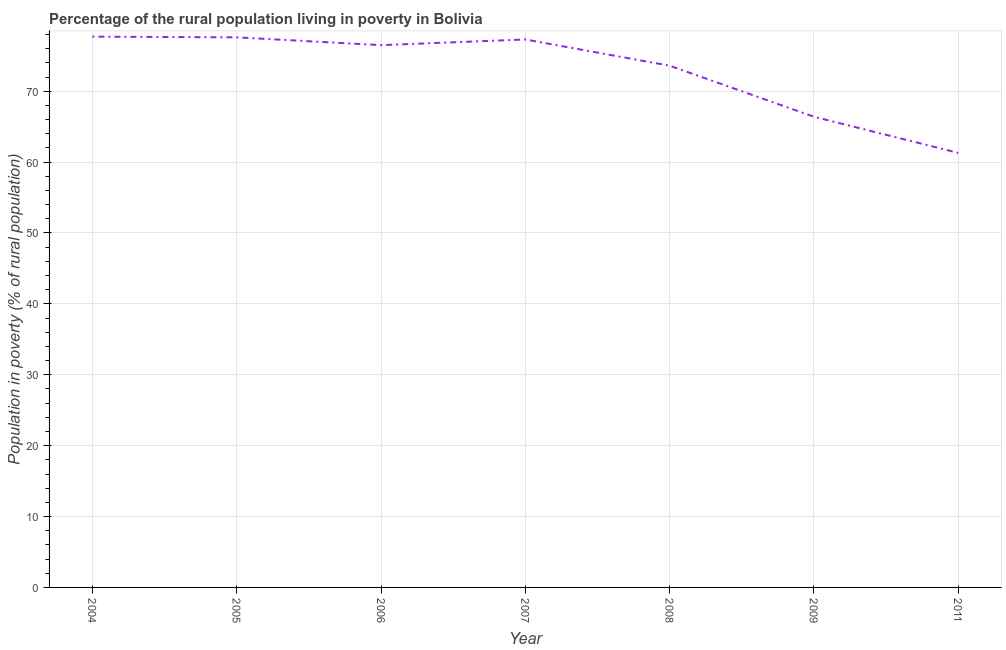What is the percentage of rural population living below poverty line in 2011?
Provide a succinct answer. 61.3. Across all years, what is the maximum percentage of rural population living below poverty line?
Provide a succinct answer. 77.7. Across all years, what is the minimum percentage of rural population living below poverty line?
Your answer should be very brief. 61.3. In which year was the percentage of rural population living below poverty line maximum?
Offer a terse response. 2004. In which year was the percentage of rural population living below poverty line minimum?
Your answer should be very brief. 2011. What is the sum of the percentage of rural population living below poverty line?
Offer a terse response. 510.4. What is the difference between the percentage of rural population living below poverty line in 2005 and 2011?
Offer a very short reply. 16.3. What is the average percentage of rural population living below poverty line per year?
Ensure brevity in your answer.  72.91. What is the median percentage of rural population living below poverty line?
Your answer should be very brief. 76.5. What is the ratio of the percentage of rural population living below poverty line in 2008 to that in 2011?
Your answer should be very brief. 1.2. Is the percentage of rural population living below poverty line in 2006 less than that in 2008?
Your answer should be compact. No. What is the difference between the highest and the second highest percentage of rural population living below poverty line?
Provide a short and direct response. 0.1. Is the sum of the percentage of rural population living below poverty line in 2006 and 2007 greater than the maximum percentage of rural population living below poverty line across all years?
Your response must be concise. Yes. What is the difference between the highest and the lowest percentage of rural population living below poverty line?
Make the answer very short. 16.4. Does the percentage of rural population living below poverty line monotonically increase over the years?
Ensure brevity in your answer.  No. How many years are there in the graph?
Your answer should be very brief. 7. Does the graph contain any zero values?
Keep it short and to the point. No. What is the title of the graph?
Ensure brevity in your answer.  Percentage of the rural population living in poverty in Bolivia. What is the label or title of the Y-axis?
Your answer should be very brief. Population in poverty (% of rural population). What is the Population in poverty (% of rural population) in 2004?
Your answer should be very brief. 77.7. What is the Population in poverty (% of rural population) in 2005?
Provide a succinct answer. 77.6. What is the Population in poverty (% of rural population) of 2006?
Provide a short and direct response. 76.5. What is the Population in poverty (% of rural population) of 2007?
Your answer should be very brief. 77.3. What is the Population in poverty (% of rural population) of 2008?
Provide a succinct answer. 73.6. What is the Population in poverty (% of rural population) of 2009?
Give a very brief answer. 66.4. What is the Population in poverty (% of rural population) in 2011?
Offer a terse response. 61.3. What is the difference between the Population in poverty (% of rural population) in 2004 and 2006?
Make the answer very short. 1.2. What is the difference between the Population in poverty (% of rural population) in 2005 and 2009?
Ensure brevity in your answer.  11.2. What is the difference between the Population in poverty (% of rural population) in 2005 and 2011?
Ensure brevity in your answer.  16.3. What is the difference between the Population in poverty (% of rural population) in 2006 and 2008?
Your response must be concise. 2.9. What is the difference between the Population in poverty (% of rural population) in 2006 and 2009?
Your response must be concise. 10.1. What is the difference between the Population in poverty (% of rural population) in 2006 and 2011?
Provide a succinct answer. 15.2. What is the ratio of the Population in poverty (% of rural population) in 2004 to that in 2005?
Your response must be concise. 1. What is the ratio of the Population in poverty (% of rural population) in 2004 to that in 2008?
Give a very brief answer. 1.06. What is the ratio of the Population in poverty (% of rural population) in 2004 to that in 2009?
Keep it short and to the point. 1.17. What is the ratio of the Population in poverty (% of rural population) in 2004 to that in 2011?
Keep it short and to the point. 1.27. What is the ratio of the Population in poverty (% of rural population) in 2005 to that in 2006?
Provide a succinct answer. 1.01. What is the ratio of the Population in poverty (% of rural population) in 2005 to that in 2008?
Your answer should be very brief. 1.05. What is the ratio of the Population in poverty (% of rural population) in 2005 to that in 2009?
Your answer should be compact. 1.17. What is the ratio of the Population in poverty (% of rural population) in 2005 to that in 2011?
Ensure brevity in your answer.  1.27. What is the ratio of the Population in poverty (% of rural population) in 2006 to that in 2007?
Provide a succinct answer. 0.99. What is the ratio of the Population in poverty (% of rural population) in 2006 to that in 2008?
Offer a terse response. 1.04. What is the ratio of the Population in poverty (% of rural population) in 2006 to that in 2009?
Offer a terse response. 1.15. What is the ratio of the Population in poverty (% of rural population) in 2006 to that in 2011?
Offer a very short reply. 1.25. What is the ratio of the Population in poverty (% of rural population) in 2007 to that in 2009?
Your answer should be very brief. 1.16. What is the ratio of the Population in poverty (% of rural population) in 2007 to that in 2011?
Provide a short and direct response. 1.26. What is the ratio of the Population in poverty (% of rural population) in 2008 to that in 2009?
Offer a very short reply. 1.11. What is the ratio of the Population in poverty (% of rural population) in 2008 to that in 2011?
Keep it short and to the point. 1.2. What is the ratio of the Population in poverty (% of rural population) in 2009 to that in 2011?
Ensure brevity in your answer.  1.08. 